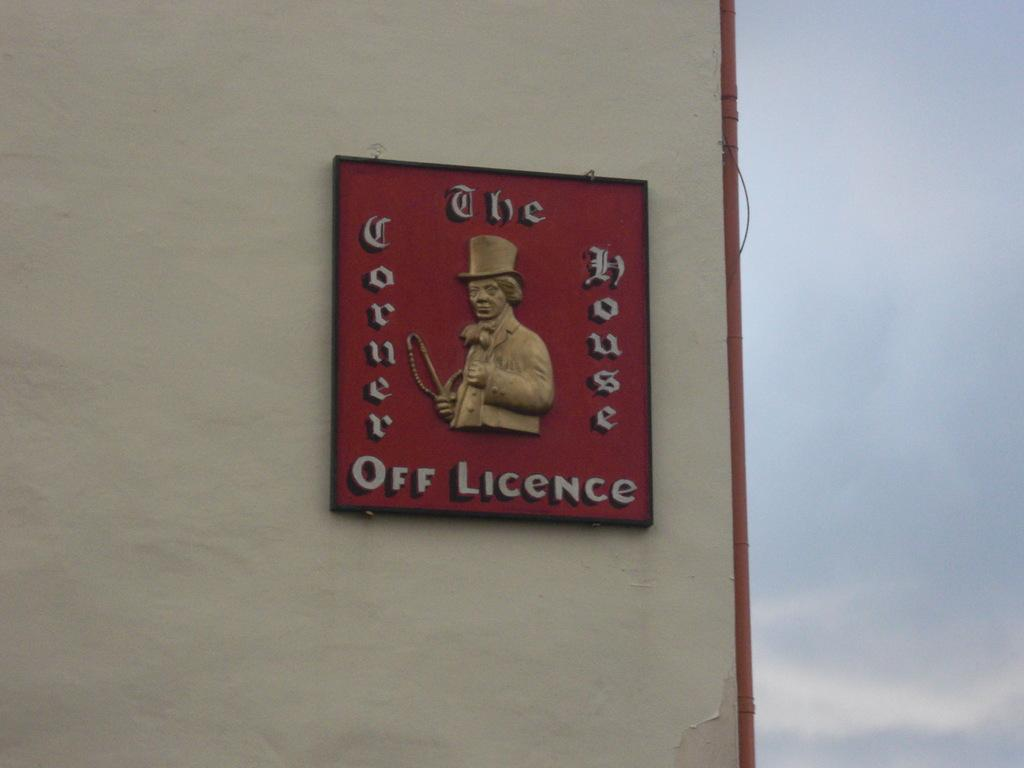Provide a one-sentence caption for the provided image. A red sign says off licence on the bottom. 